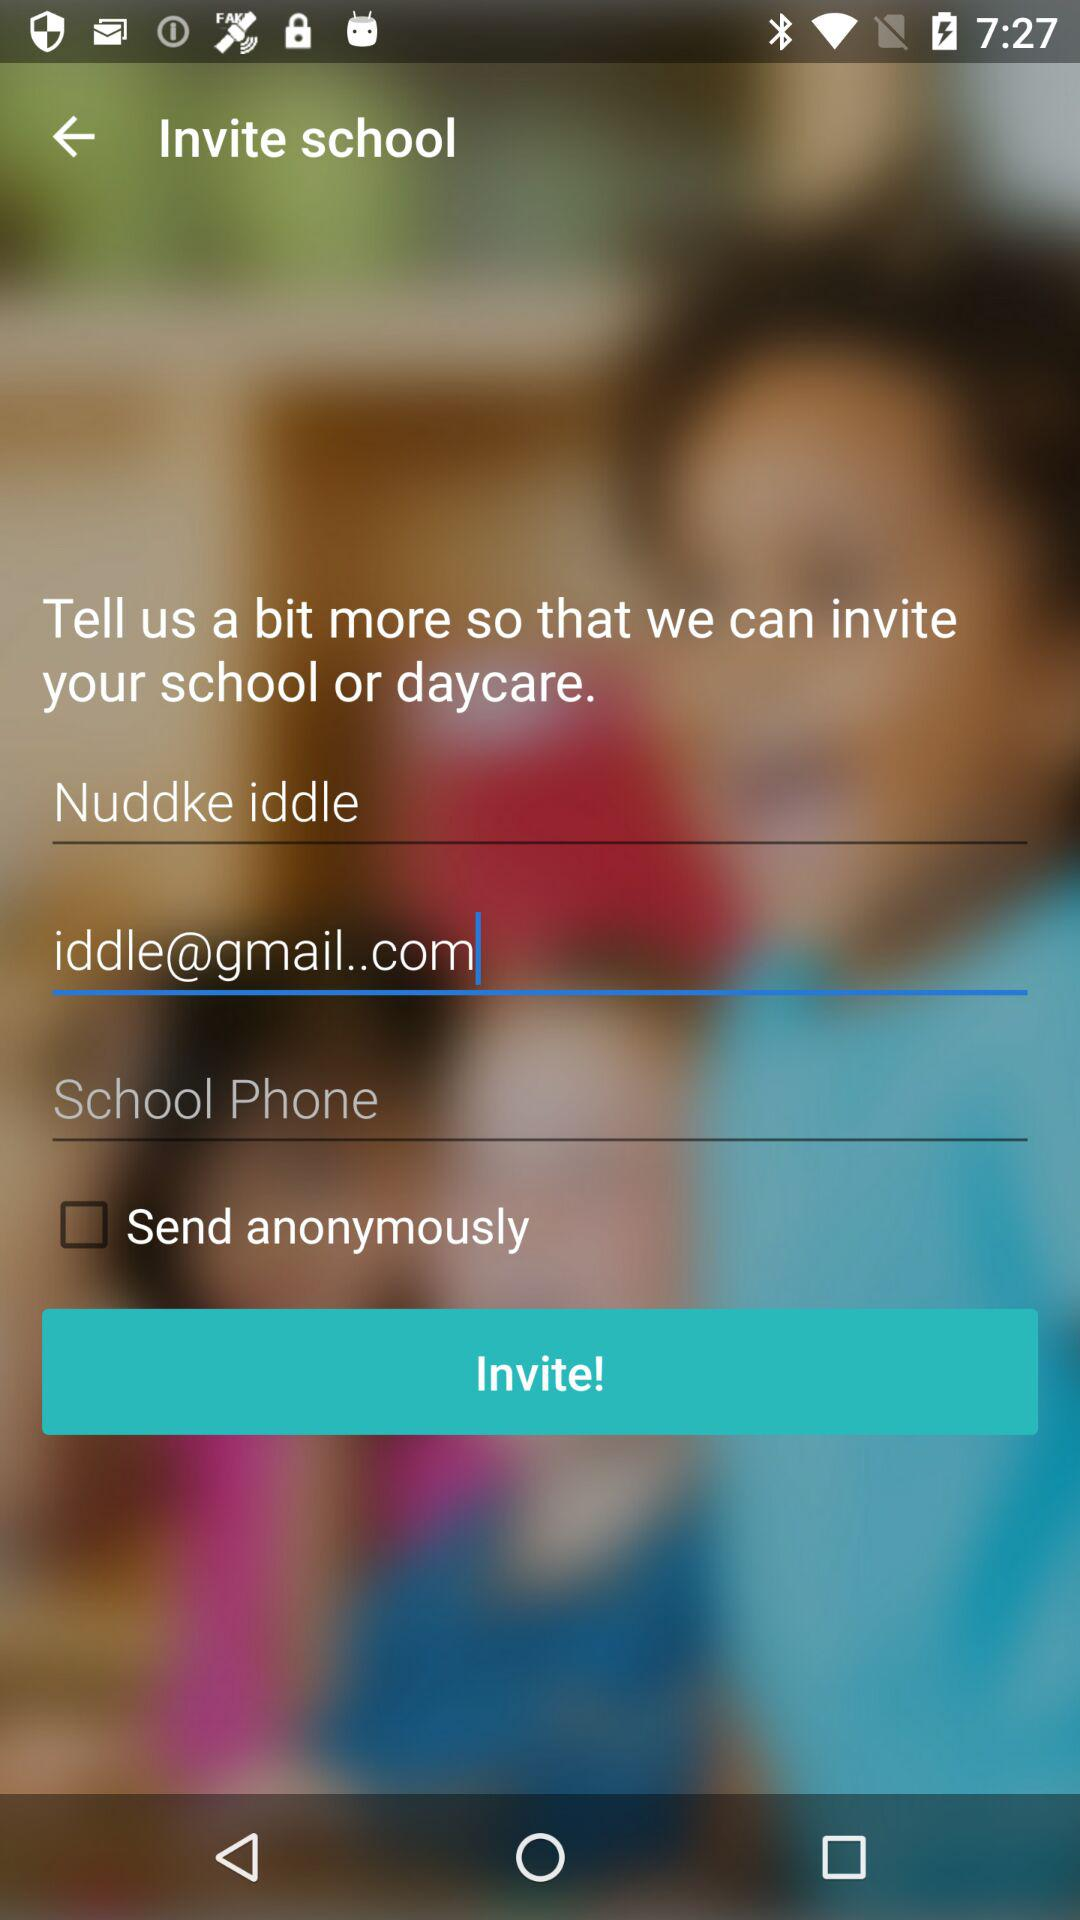What is the entered email address? The entered email address is iddle@gmail.com. 